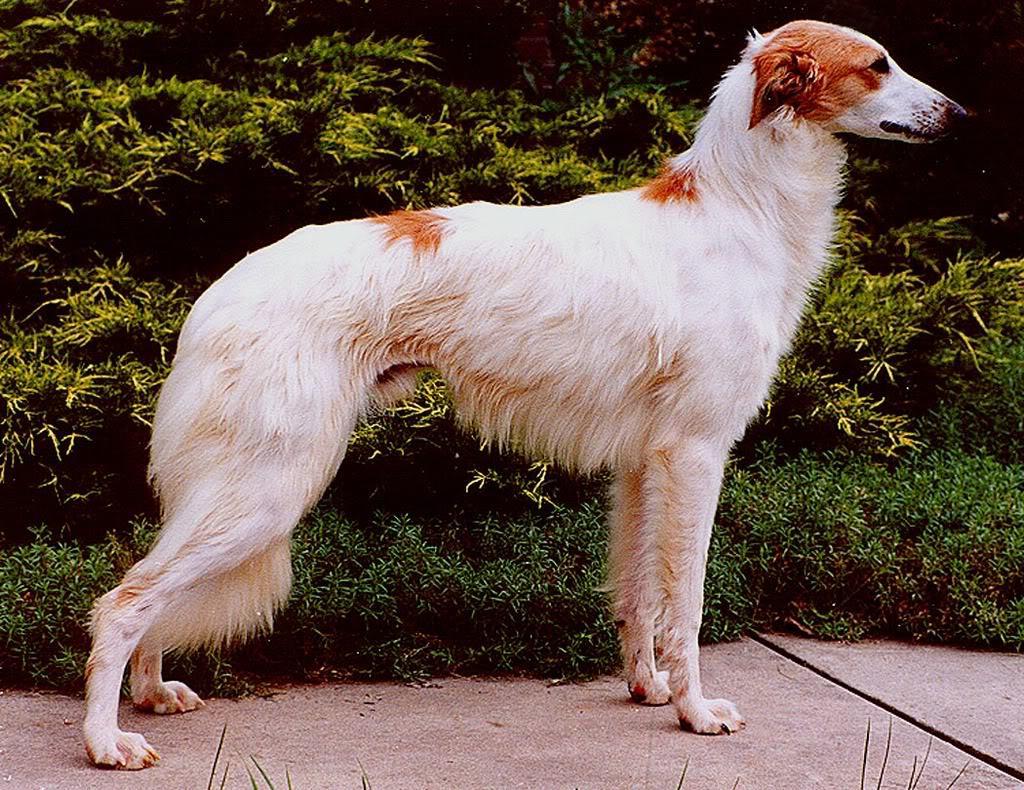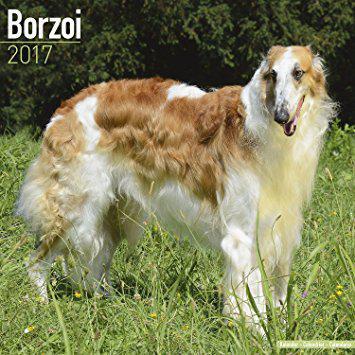The first image is the image on the left, the second image is the image on the right. For the images displayed, is the sentence "A dog is standing in a field in the image on the right." factually correct? Answer yes or no. Yes. The first image is the image on the left, the second image is the image on the right. For the images displayed, is the sentence "The dog in the left image is standing on the sidewalk." factually correct? Answer yes or no. Yes. 